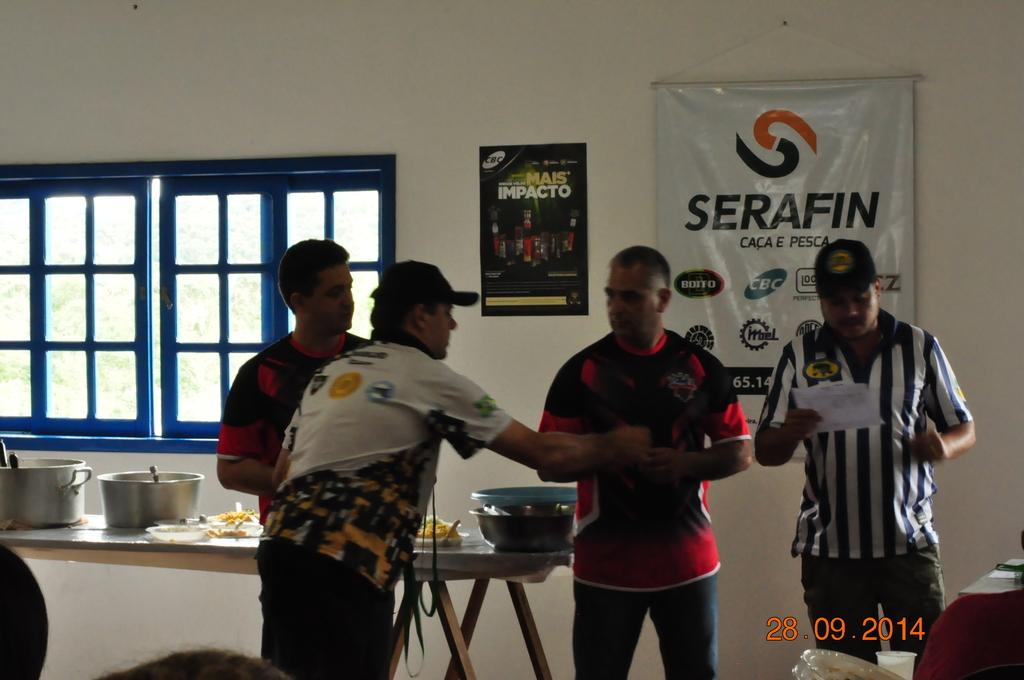Provide a one-sentence caption for the provided image. Four men appear to be having a heated conversation in front of a poster for Serafin. 